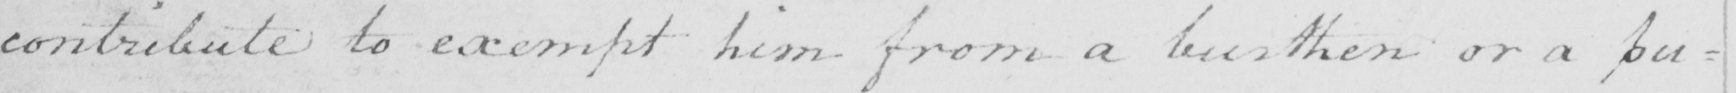Transcribe the text shown in this historical manuscript line. contribute to exempt him from a burthen or a pu= 